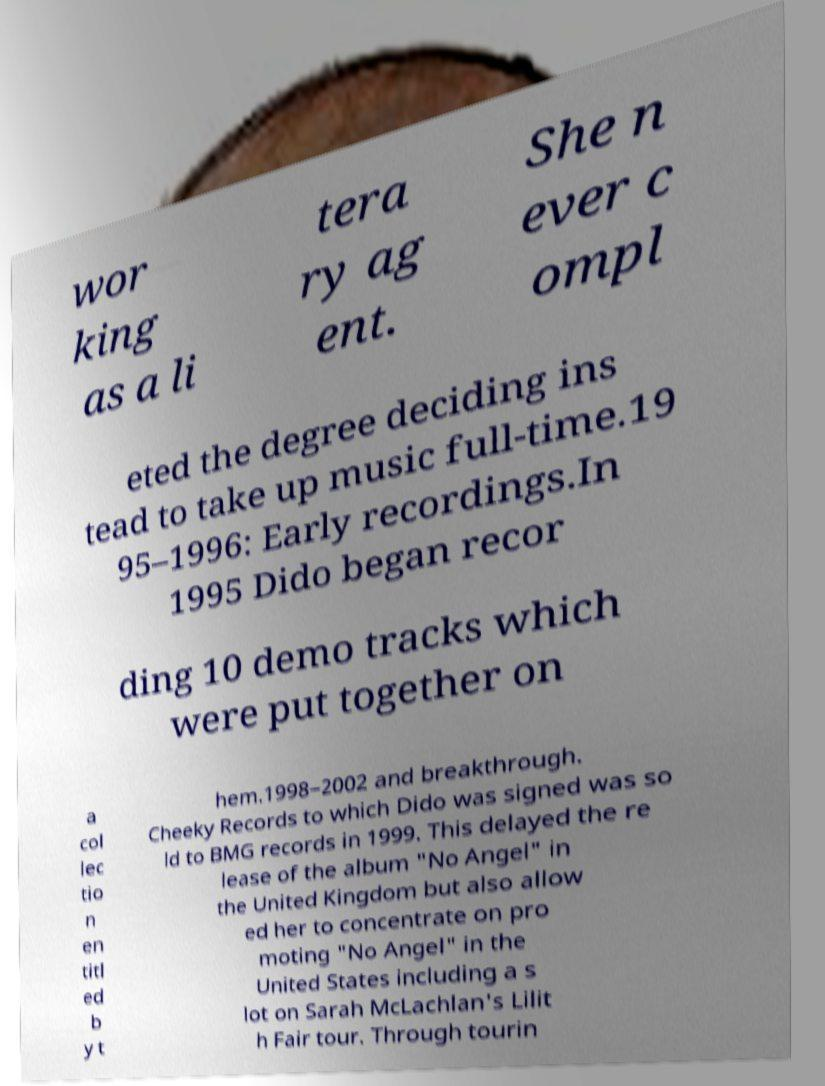Please identify and transcribe the text found in this image. wor king as a li tera ry ag ent. She n ever c ompl eted the degree deciding ins tead to take up music full-time.19 95–1996: Early recordings.In 1995 Dido began recor ding 10 demo tracks which were put together on a col lec tio n en titl ed b y t hem.1998–2002 and breakthrough. Cheeky Records to which Dido was signed was so ld to BMG records in 1999. This delayed the re lease of the album "No Angel" in the United Kingdom but also allow ed her to concentrate on pro moting "No Angel" in the United States including a s lot on Sarah McLachlan's Lilit h Fair tour. Through tourin 